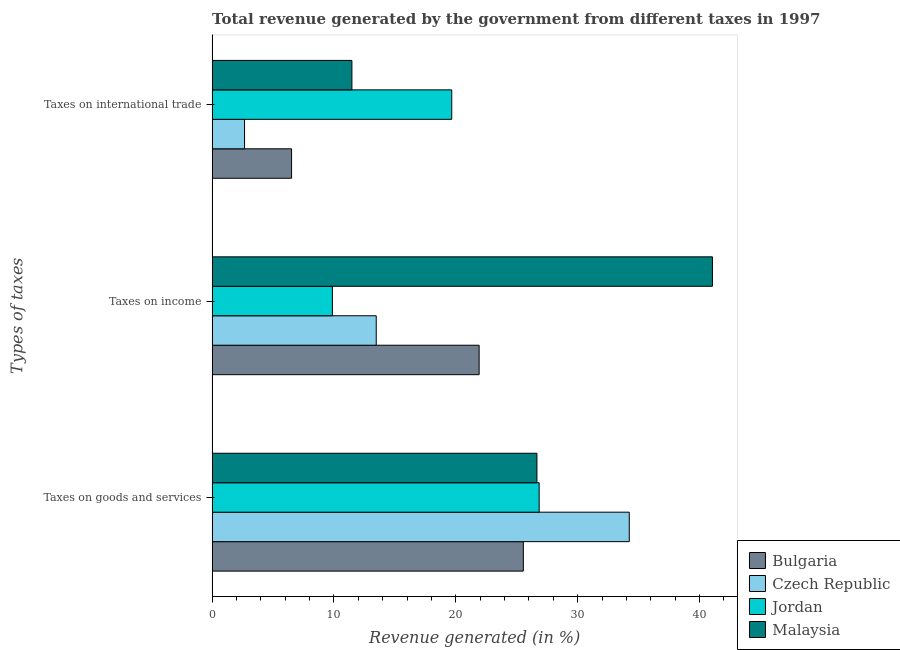Are the number of bars per tick equal to the number of legend labels?
Ensure brevity in your answer.  Yes. Are the number of bars on each tick of the Y-axis equal?
Provide a short and direct response. Yes. How many bars are there on the 1st tick from the bottom?
Make the answer very short. 4. What is the label of the 2nd group of bars from the top?
Your answer should be very brief. Taxes on income. What is the percentage of revenue generated by tax on international trade in Malaysia?
Your answer should be compact. 11.47. Across all countries, what is the maximum percentage of revenue generated by tax on international trade?
Ensure brevity in your answer.  19.66. Across all countries, what is the minimum percentage of revenue generated by tax on international trade?
Give a very brief answer. 2.66. In which country was the percentage of revenue generated by taxes on goods and services maximum?
Make the answer very short. Czech Republic. In which country was the percentage of revenue generated by taxes on income minimum?
Your answer should be compact. Jordan. What is the total percentage of revenue generated by taxes on goods and services in the graph?
Keep it short and to the point. 113.26. What is the difference between the percentage of revenue generated by tax on international trade in Malaysia and that in Czech Republic?
Offer a very short reply. 8.81. What is the difference between the percentage of revenue generated by taxes on income in Jordan and the percentage of revenue generated by taxes on goods and services in Czech Republic?
Give a very brief answer. -24.36. What is the average percentage of revenue generated by tax on international trade per country?
Offer a terse response. 10.08. What is the difference between the percentage of revenue generated by taxes on goods and services and percentage of revenue generated by taxes on income in Czech Republic?
Provide a succinct answer. 20.76. What is the ratio of the percentage of revenue generated by taxes on income in Jordan to that in Czech Republic?
Your answer should be compact. 0.73. Is the difference between the percentage of revenue generated by taxes on income in Bulgaria and Czech Republic greater than the difference between the percentage of revenue generated by taxes on goods and services in Bulgaria and Czech Republic?
Provide a short and direct response. Yes. What is the difference between the highest and the second highest percentage of revenue generated by tax on international trade?
Ensure brevity in your answer.  8.19. What is the difference between the highest and the lowest percentage of revenue generated by taxes on goods and services?
Your answer should be very brief. 8.69. In how many countries, is the percentage of revenue generated by taxes on goods and services greater than the average percentage of revenue generated by taxes on goods and services taken over all countries?
Make the answer very short. 1. Is the sum of the percentage of revenue generated by taxes on income in Bulgaria and Jordan greater than the maximum percentage of revenue generated by taxes on goods and services across all countries?
Your answer should be very brief. No. What does the 1st bar from the top in Taxes on goods and services represents?
Provide a succinct answer. Malaysia. What does the 2nd bar from the bottom in Taxes on international trade represents?
Keep it short and to the point. Czech Republic. Is it the case that in every country, the sum of the percentage of revenue generated by taxes on goods and services and percentage of revenue generated by taxes on income is greater than the percentage of revenue generated by tax on international trade?
Keep it short and to the point. Yes. How many bars are there?
Give a very brief answer. 12. Where does the legend appear in the graph?
Your response must be concise. Bottom right. How many legend labels are there?
Make the answer very short. 4. How are the legend labels stacked?
Make the answer very short. Vertical. What is the title of the graph?
Offer a very short reply. Total revenue generated by the government from different taxes in 1997. Does "Romania" appear as one of the legend labels in the graph?
Provide a succinct answer. No. What is the label or title of the X-axis?
Keep it short and to the point. Revenue generated (in %). What is the label or title of the Y-axis?
Make the answer very short. Types of taxes. What is the Revenue generated (in %) in Bulgaria in Taxes on goods and services?
Make the answer very short. 25.54. What is the Revenue generated (in %) in Czech Republic in Taxes on goods and services?
Provide a succinct answer. 34.23. What is the Revenue generated (in %) of Jordan in Taxes on goods and services?
Your answer should be compact. 26.84. What is the Revenue generated (in %) in Malaysia in Taxes on goods and services?
Provide a short and direct response. 26.65. What is the Revenue generated (in %) in Bulgaria in Taxes on income?
Ensure brevity in your answer.  21.91. What is the Revenue generated (in %) in Czech Republic in Taxes on income?
Your response must be concise. 13.47. What is the Revenue generated (in %) of Jordan in Taxes on income?
Your response must be concise. 9.87. What is the Revenue generated (in %) of Malaysia in Taxes on income?
Keep it short and to the point. 41.06. What is the Revenue generated (in %) in Bulgaria in Taxes on international trade?
Provide a succinct answer. 6.52. What is the Revenue generated (in %) of Czech Republic in Taxes on international trade?
Your answer should be compact. 2.66. What is the Revenue generated (in %) of Jordan in Taxes on international trade?
Your response must be concise. 19.66. What is the Revenue generated (in %) of Malaysia in Taxes on international trade?
Ensure brevity in your answer.  11.47. Across all Types of taxes, what is the maximum Revenue generated (in %) in Bulgaria?
Offer a terse response. 25.54. Across all Types of taxes, what is the maximum Revenue generated (in %) of Czech Republic?
Provide a short and direct response. 34.23. Across all Types of taxes, what is the maximum Revenue generated (in %) of Jordan?
Make the answer very short. 26.84. Across all Types of taxes, what is the maximum Revenue generated (in %) in Malaysia?
Your answer should be very brief. 41.06. Across all Types of taxes, what is the minimum Revenue generated (in %) of Bulgaria?
Provide a succinct answer. 6.52. Across all Types of taxes, what is the minimum Revenue generated (in %) of Czech Republic?
Offer a very short reply. 2.66. Across all Types of taxes, what is the minimum Revenue generated (in %) in Jordan?
Offer a terse response. 9.87. Across all Types of taxes, what is the minimum Revenue generated (in %) of Malaysia?
Ensure brevity in your answer.  11.47. What is the total Revenue generated (in %) of Bulgaria in the graph?
Make the answer very short. 53.97. What is the total Revenue generated (in %) of Czech Republic in the graph?
Offer a terse response. 50.36. What is the total Revenue generated (in %) of Jordan in the graph?
Make the answer very short. 56.37. What is the total Revenue generated (in %) in Malaysia in the graph?
Give a very brief answer. 79.18. What is the difference between the Revenue generated (in %) in Bulgaria in Taxes on goods and services and that in Taxes on income?
Your answer should be compact. 3.63. What is the difference between the Revenue generated (in %) of Czech Republic in Taxes on goods and services and that in Taxes on income?
Your answer should be very brief. 20.76. What is the difference between the Revenue generated (in %) of Jordan in Taxes on goods and services and that in Taxes on income?
Your answer should be very brief. 16.97. What is the difference between the Revenue generated (in %) of Malaysia in Taxes on goods and services and that in Taxes on income?
Offer a very short reply. -14.4. What is the difference between the Revenue generated (in %) of Bulgaria in Taxes on goods and services and that in Taxes on international trade?
Your response must be concise. 19.02. What is the difference between the Revenue generated (in %) of Czech Republic in Taxes on goods and services and that in Taxes on international trade?
Your answer should be very brief. 31.57. What is the difference between the Revenue generated (in %) in Jordan in Taxes on goods and services and that in Taxes on international trade?
Ensure brevity in your answer.  7.17. What is the difference between the Revenue generated (in %) in Malaysia in Taxes on goods and services and that in Taxes on international trade?
Provide a succinct answer. 15.18. What is the difference between the Revenue generated (in %) of Bulgaria in Taxes on income and that in Taxes on international trade?
Your answer should be compact. 15.39. What is the difference between the Revenue generated (in %) in Czech Republic in Taxes on income and that in Taxes on international trade?
Offer a very short reply. 10.81. What is the difference between the Revenue generated (in %) in Jordan in Taxes on income and that in Taxes on international trade?
Your response must be concise. -9.79. What is the difference between the Revenue generated (in %) in Malaysia in Taxes on income and that in Taxes on international trade?
Provide a succinct answer. 29.59. What is the difference between the Revenue generated (in %) in Bulgaria in Taxes on goods and services and the Revenue generated (in %) in Czech Republic in Taxes on income?
Provide a short and direct response. 12.07. What is the difference between the Revenue generated (in %) in Bulgaria in Taxes on goods and services and the Revenue generated (in %) in Jordan in Taxes on income?
Offer a very short reply. 15.67. What is the difference between the Revenue generated (in %) in Bulgaria in Taxes on goods and services and the Revenue generated (in %) in Malaysia in Taxes on income?
Give a very brief answer. -15.52. What is the difference between the Revenue generated (in %) in Czech Republic in Taxes on goods and services and the Revenue generated (in %) in Jordan in Taxes on income?
Provide a short and direct response. 24.36. What is the difference between the Revenue generated (in %) of Czech Republic in Taxes on goods and services and the Revenue generated (in %) of Malaysia in Taxes on income?
Offer a terse response. -6.83. What is the difference between the Revenue generated (in %) of Jordan in Taxes on goods and services and the Revenue generated (in %) of Malaysia in Taxes on income?
Ensure brevity in your answer.  -14.22. What is the difference between the Revenue generated (in %) of Bulgaria in Taxes on goods and services and the Revenue generated (in %) of Czech Republic in Taxes on international trade?
Your response must be concise. 22.88. What is the difference between the Revenue generated (in %) in Bulgaria in Taxes on goods and services and the Revenue generated (in %) in Jordan in Taxes on international trade?
Your answer should be very brief. 5.88. What is the difference between the Revenue generated (in %) of Bulgaria in Taxes on goods and services and the Revenue generated (in %) of Malaysia in Taxes on international trade?
Offer a terse response. 14.07. What is the difference between the Revenue generated (in %) in Czech Republic in Taxes on goods and services and the Revenue generated (in %) in Jordan in Taxes on international trade?
Give a very brief answer. 14.57. What is the difference between the Revenue generated (in %) in Czech Republic in Taxes on goods and services and the Revenue generated (in %) in Malaysia in Taxes on international trade?
Provide a succinct answer. 22.76. What is the difference between the Revenue generated (in %) in Jordan in Taxes on goods and services and the Revenue generated (in %) in Malaysia in Taxes on international trade?
Make the answer very short. 15.37. What is the difference between the Revenue generated (in %) of Bulgaria in Taxes on income and the Revenue generated (in %) of Czech Republic in Taxes on international trade?
Offer a terse response. 19.25. What is the difference between the Revenue generated (in %) in Bulgaria in Taxes on income and the Revenue generated (in %) in Jordan in Taxes on international trade?
Ensure brevity in your answer.  2.25. What is the difference between the Revenue generated (in %) in Bulgaria in Taxes on income and the Revenue generated (in %) in Malaysia in Taxes on international trade?
Provide a short and direct response. 10.44. What is the difference between the Revenue generated (in %) in Czech Republic in Taxes on income and the Revenue generated (in %) in Jordan in Taxes on international trade?
Your response must be concise. -6.2. What is the difference between the Revenue generated (in %) of Czech Republic in Taxes on income and the Revenue generated (in %) of Malaysia in Taxes on international trade?
Keep it short and to the point. 2. What is the difference between the Revenue generated (in %) in Jordan in Taxes on income and the Revenue generated (in %) in Malaysia in Taxes on international trade?
Make the answer very short. -1.6. What is the average Revenue generated (in %) in Bulgaria per Types of taxes?
Provide a succinct answer. 17.99. What is the average Revenue generated (in %) in Czech Republic per Types of taxes?
Give a very brief answer. 16.79. What is the average Revenue generated (in %) of Jordan per Types of taxes?
Keep it short and to the point. 18.79. What is the average Revenue generated (in %) of Malaysia per Types of taxes?
Your response must be concise. 26.39. What is the difference between the Revenue generated (in %) of Bulgaria and Revenue generated (in %) of Czech Republic in Taxes on goods and services?
Your response must be concise. -8.69. What is the difference between the Revenue generated (in %) of Bulgaria and Revenue generated (in %) of Jordan in Taxes on goods and services?
Offer a very short reply. -1.3. What is the difference between the Revenue generated (in %) of Bulgaria and Revenue generated (in %) of Malaysia in Taxes on goods and services?
Offer a terse response. -1.12. What is the difference between the Revenue generated (in %) in Czech Republic and Revenue generated (in %) in Jordan in Taxes on goods and services?
Your answer should be very brief. 7.39. What is the difference between the Revenue generated (in %) in Czech Republic and Revenue generated (in %) in Malaysia in Taxes on goods and services?
Make the answer very short. 7.58. What is the difference between the Revenue generated (in %) of Jordan and Revenue generated (in %) of Malaysia in Taxes on goods and services?
Offer a terse response. 0.18. What is the difference between the Revenue generated (in %) of Bulgaria and Revenue generated (in %) of Czech Republic in Taxes on income?
Offer a very short reply. 8.44. What is the difference between the Revenue generated (in %) of Bulgaria and Revenue generated (in %) of Jordan in Taxes on income?
Give a very brief answer. 12.04. What is the difference between the Revenue generated (in %) of Bulgaria and Revenue generated (in %) of Malaysia in Taxes on income?
Make the answer very short. -19.14. What is the difference between the Revenue generated (in %) of Czech Republic and Revenue generated (in %) of Jordan in Taxes on income?
Keep it short and to the point. 3.6. What is the difference between the Revenue generated (in %) of Czech Republic and Revenue generated (in %) of Malaysia in Taxes on income?
Your answer should be compact. -27.59. What is the difference between the Revenue generated (in %) of Jordan and Revenue generated (in %) of Malaysia in Taxes on income?
Offer a very short reply. -31.19. What is the difference between the Revenue generated (in %) in Bulgaria and Revenue generated (in %) in Czech Republic in Taxes on international trade?
Make the answer very short. 3.86. What is the difference between the Revenue generated (in %) of Bulgaria and Revenue generated (in %) of Jordan in Taxes on international trade?
Your response must be concise. -13.14. What is the difference between the Revenue generated (in %) in Bulgaria and Revenue generated (in %) in Malaysia in Taxes on international trade?
Your response must be concise. -4.95. What is the difference between the Revenue generated (in %) in Czech Republic and Revenue generated (in %) in Jordan in Taxes on international trade?
Offer a very short reply. -17. What is the difference between the Revenue generated (in %) of Czech Republic and Revenue generated (in %) of Malaysia in Taxes on international trade?
Provide a short and direct response. -8.81. What is the difference between the Revenue generated (in %) of Jordan and Revenue generated (in %) of Malaysia in Taxes on international trade?
Provide a succinct answer. 8.19. What is the ratio of the Revenue generated (in %) in Bulgaria in Taxes on goods and services to that in Taxes on income?
Your response must be concise. 1.17. What is the ratio of the Revenue generated (in %) of Czech Republic in Taxes on goods and services to that in Taxes on income?
Make the answer very short. 2.54. What is the ratio of the Revenue generated (in %) in Jordan in Taxes on goods and services to that in Taxes on income?
Offer a terse response. 2.72. What is the ratio of the Revenue generated (in %) in Malaysia in Taxes on goods and services to that in Taxes on income?
Provide a succinct answer. 0.65. What is the ratio of the Revenue generated (in %) in Bulgaria in Taxes on goods and services to that in Taxes on international trade?
Offer a very short reply. 3.92. What is the ratio of the Revenue generated (in %) in Czech Republic in Taxes on goods and services to that in Taxes on international trade?
Keep it short and to the point. 12.87. What is the ratio of the Revenue generated (in %) in Jordan in Taxes on goods and services to that in Taxes on international trade?
Offer a terse response. 1.36. What is the ratio of the Revenue generated (in %) of Malaysia in Taxes on goods and services to that in Taxes on international trade?
Your answer should be very brief. 2.32. What is the ratio of the Revenue generated (in %) in Bulgaria in Taxes on income to that in Taxes on international trade?
Keep it short and to the point. 3.36. What is the ratio of the Revenue generated (in %) in Czech Republic in Taxes on income to that in Taxes on international trade?
Your response must be concise. 5.06. What is the ratio of the Revenue generated (in %) of Jordan in Taxes on income to that in Taxes on international trade?
Offer a very short reply. 0.5. What is the ratio of the Revenue generated (in %) of Malaysia in Taxes on income to that in Taxes on international trade?
Offer a terse response. 3.58. What is the difference between the highest and the second highest Revenue generated (in %) of Bulgaria?
Make the answer very short. 3.63. What is the difference between the highest and the second highest Revenue generated (in %) in Czech Republic?
Provide a succinct answer. 20.76. What is the difference between the highest and the second highest Revenue generated (in %) of Jordan?
Offer a very short reply. 7.17. What is the difference between the highest and the second highest Revenue generated (in %) in Malaysia?
Your response must be concise. 14.4. What is the difference between the highest and the lowest Revenue generated (in %) of Bulgaria?
Keep it short and to the point. 19.02. What is the difference between the highest and the lowest Revenue generated (in %) in Czech Republic?
Ensure brevity in your answer.  31.57. What is the difference between the highest and the lowest Revenue generated (in %) of Jordan?
Offer a very short reply. 16.97. What is the difference between the highest and the lowest Revenue generated (in %) in Malaysia?
Offer a very short reply. 29.59. 